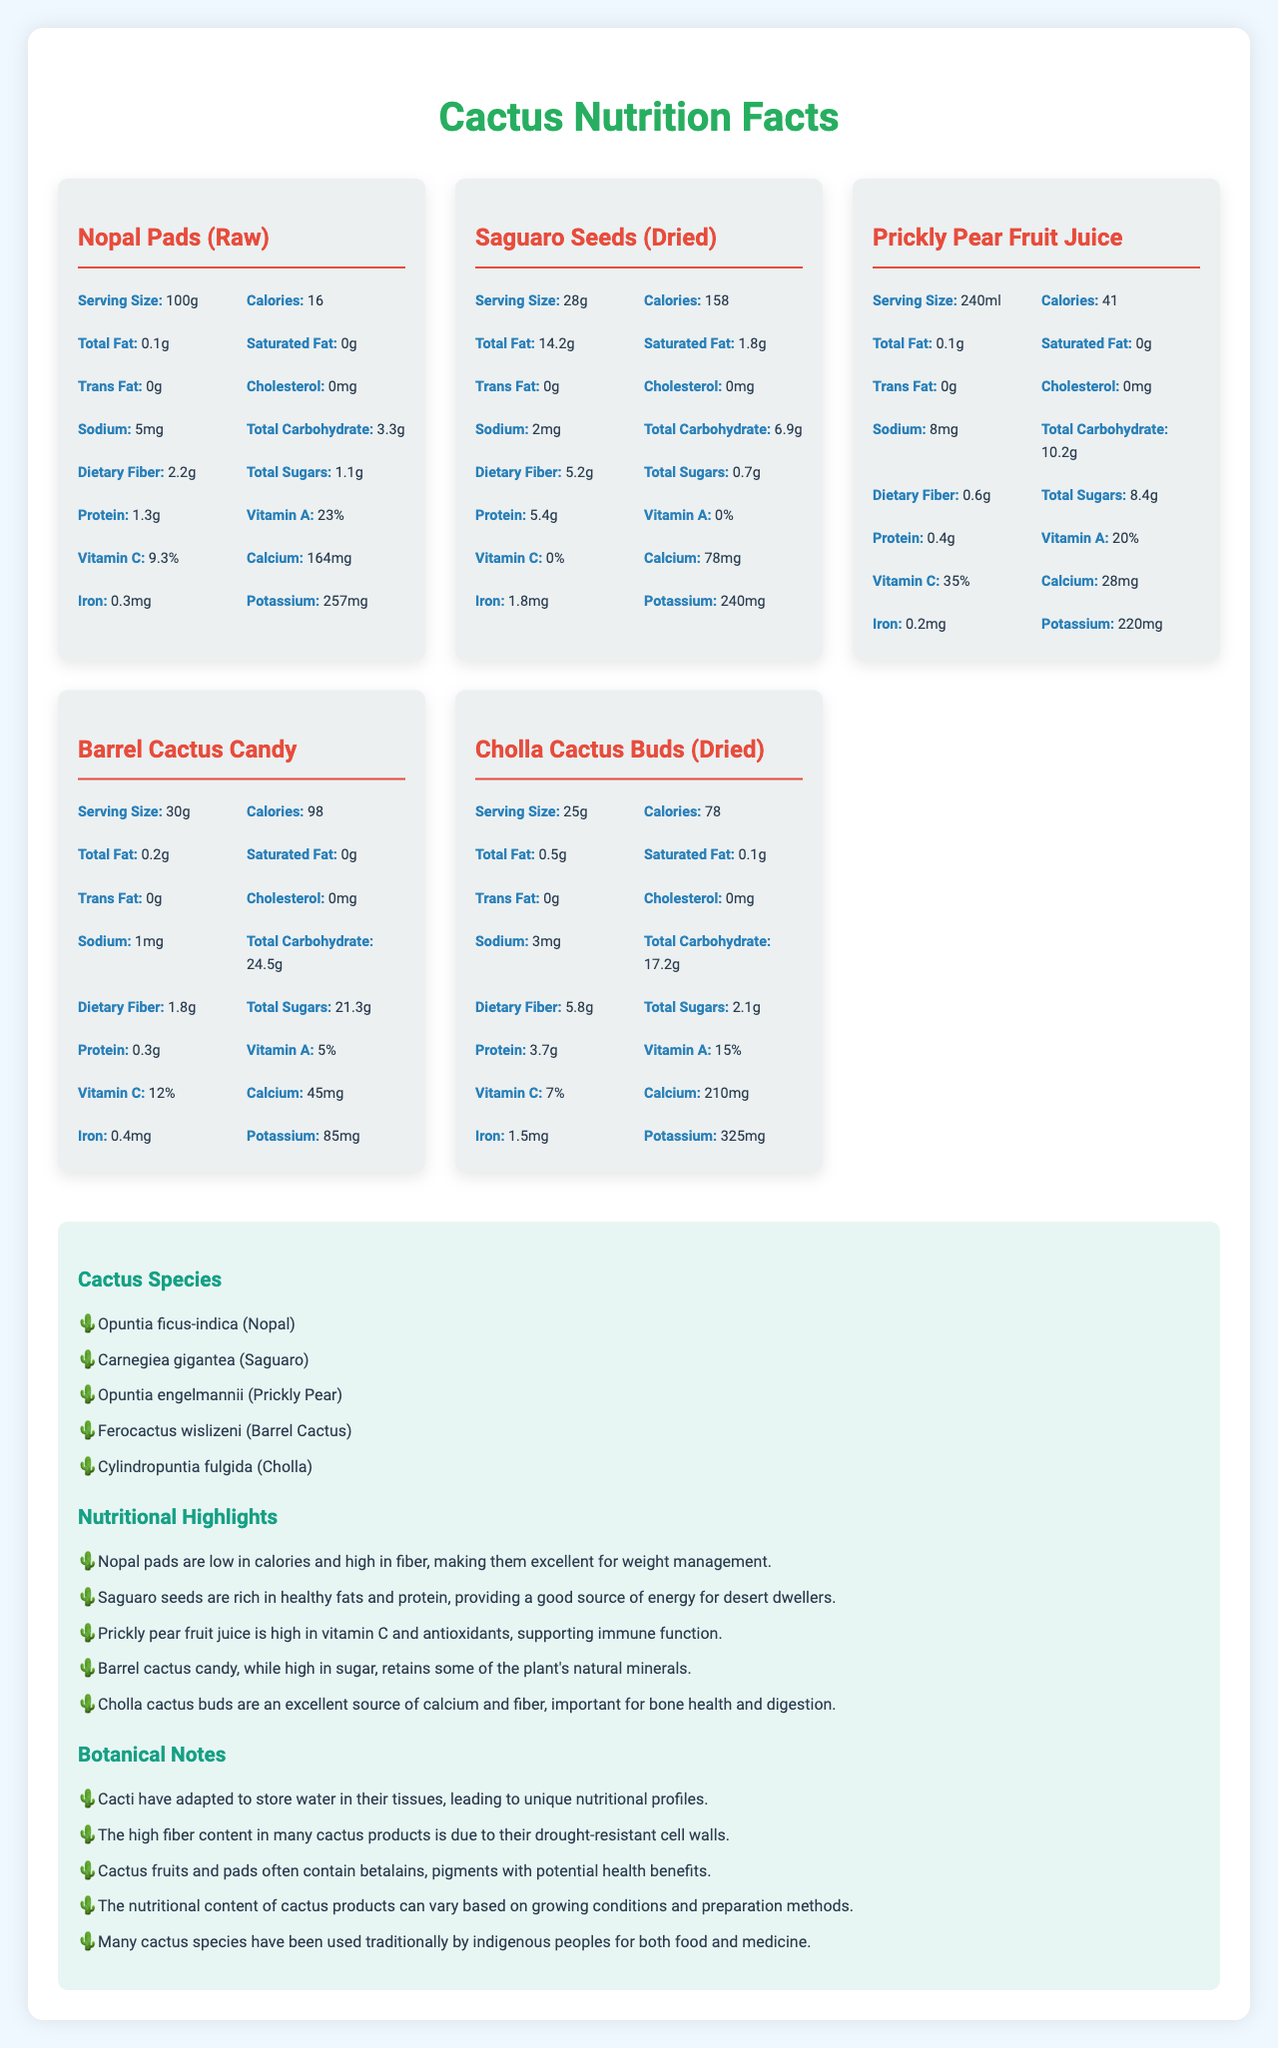what is the serving size of Nopal Pads (Raw)? The serving size of Nopal Pads (Raw) is listed as 100g in the document.
Answer: 100g what is the total carbohydrate content of Prickly Pear Fruit Juice? The total carbohydrate content of Prickly Pear Fruit Juice is 10.2g, as shown in the nutritional information.
Answer: 10.2g how many calories are in a serving of Barrel Cactus Candy? A serving of Barrel Cactus Candy contains 98 calories.
Answer: 98 what cactus-based food product is highest in protein per serving? Saguaro Seeds (Dried) have the highest protein content at 5.4g per serving.
Answer: Saguaro Seeds (Dried) which product contains the most dietary fiber? Cholla Cactus Buds (Dried) contain the most dietary fiber with 5.8g per serving.
Answer: Cholla Cactus Buds (Dried) which cactus product provides the highest percentage of vitamin C? A. Nopal Pads (Raw) B. Saguaro Seeds (Dried) C. Prickly Pear Fruit Juice D. Barrel Cactus Candy Prickly Pear Fruit Juice has 35% vitamin C, the highest among the listed products.
Answer: C. Prickly Pear Fruit Juice which cactus food product has the lowest sodium content? A. Nopal Pads (Raw) B. Saguaro Seeds (Dried) C. Prickly Pear Fruit Juice D. Barrel Cactus Candy Saguaro Seeds (Dried) have the lowest sodium content at 2mg per serving.
Answer: B. Saguaro Seeds (Dried) is the total sugar content of Barrel Cactus Candy higher than that of Prickly Pear Fruit Juice? Barrel Cactus Candy contains 21.3g of total sugars, while Prickly Pear Fruit Juice contains 8.4g.
Answer: Yes what is the average calorie count per serving of all listed products? The document doesn't provide enough information to calculate the average calorie count per serving for all products cumulatively.
Answer: Not enough information 